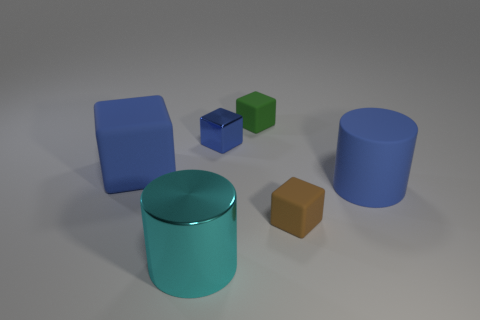Do the brown object and the green thing have the same size?
Keep it short and to the point. Yes. How many other objects are there of the same shape as the cyan shiny object?
Offer a terse response. 1. There is a big blue thing on the right side of the large cyan thing; what is its shape?
Keep it short and to the point. Cylinder. There is a blue object that is on the right side of the blue shiny block; is its shape the same as the big metallic object in front of the green object?
Your response must be concise. Yes. Are there an equal number of tiny things to the right of the big blue rubber cylinder and blue rubber spheres?
Make the answer very short. Yes. There is a small blue object that is the same shape as the tiny brown rubber object; what is it made of?
Your answer should be very brief. Metal. There is a large blue matte thing that is to the right of the rubber cube that is behind the small blue cube; what is its shape?
Your answer should be very brief. Cylinder. Do the blue object to the right of the green object and the green thing have the same material?
Your answer should be very brief. Yes. Are there an equal number of blocks on the right side of the brown object and green cubes behind the cyan cylinder?
Make the answer very short. No. There is a large cylinder that is the same color as the metallic cube; what is it made of?
Provide a succinct answer. Rubber. 